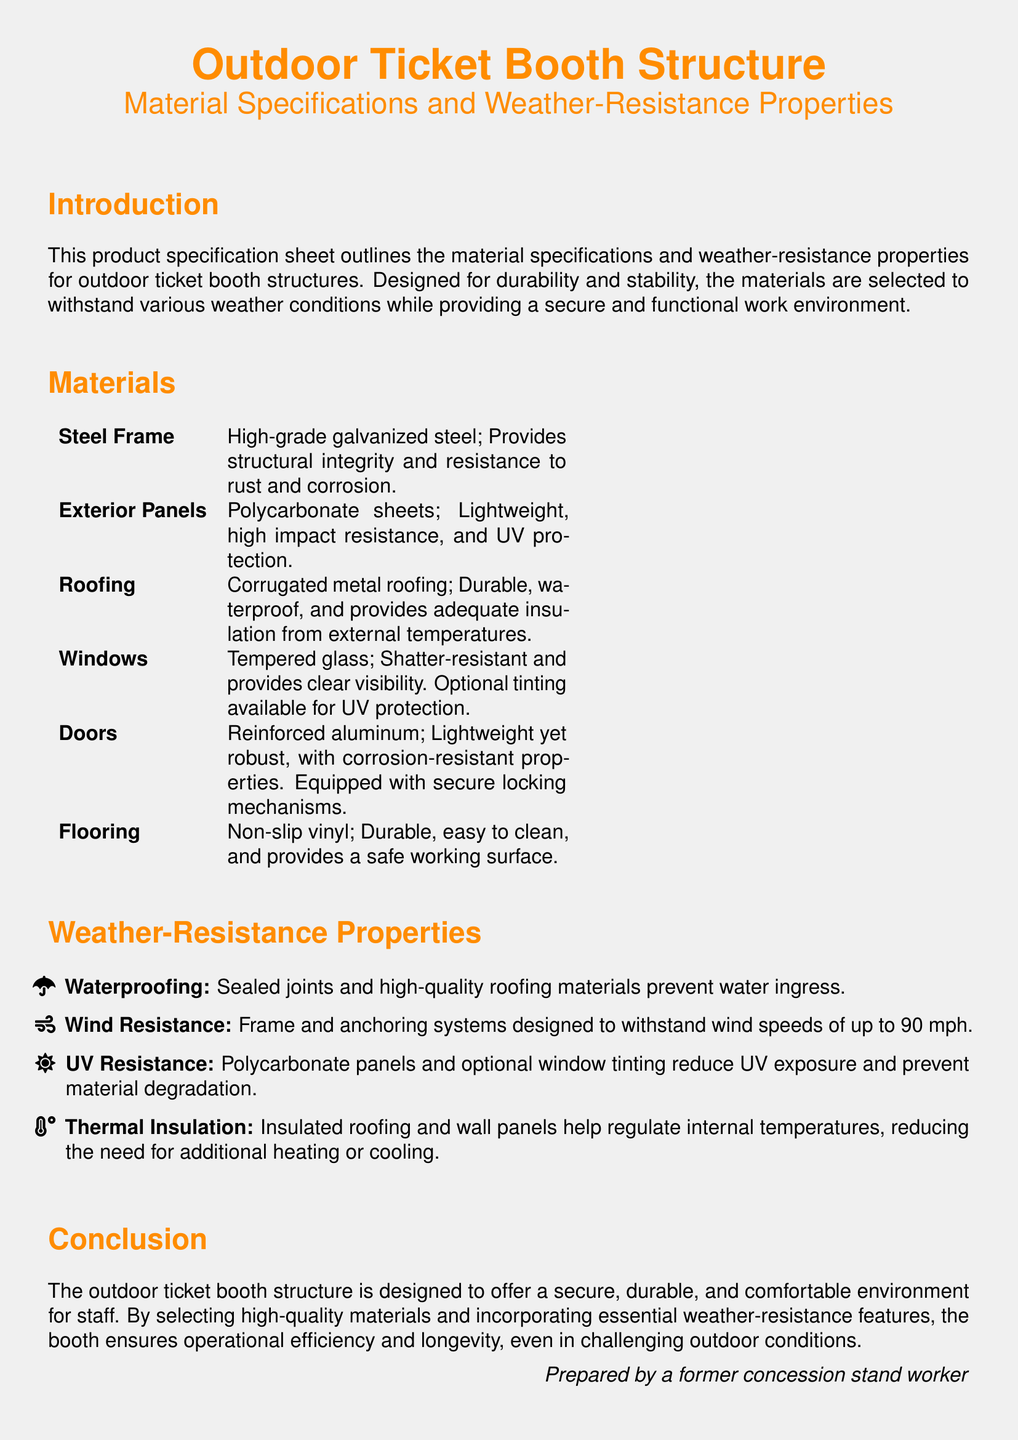What is the primary material for the frame? The primary material for the frame is high-grade galvanized steel, which is mentioned in the materials section.
Answer: high-grade galvanized steel What is the wind resistance rating of the booth? The wind resistance rating is specified in the weather-resistance properties as being able to withstand wind speeds of up to 90 mph.
Answer: 90 mph Which material is used for the exterior panels? The exterior panels are made from polycarbonate sheets, as noted in the materials section.
Answer: Polycarbonate sheets What type of glass is used for the windows? The document states that the windows are made from tempered glass, which is mentioned in the materials section.
Answer: Tempered glass What feature provides thermal insulation? The document refers to insulated roofing and wall panels as providing thermal insulation in the weather-resistance properties.
Answer: Insulated roofing and wall panels How are the doors described? The doors are described as reinforced aluminum, with corrosion-resistant properties and secure locking mechanisms.
Answer: Reinforced aluminum What is the flooring material? The flooring material is specified as non-slip vinyl in the materials section.
Answer: Non-slip vinyl What additional protection is available for windows? The document mentions that optional tinting is available for UV protection for the windows.
Answer: Optional tinting What is the purpose of selecting high-quality materials? The conclusion states that high-quality materials are selected to ensure operational efficiency and longevity in the outdoor ticket booth structure.
Answer: Operational efficiency and longevity 